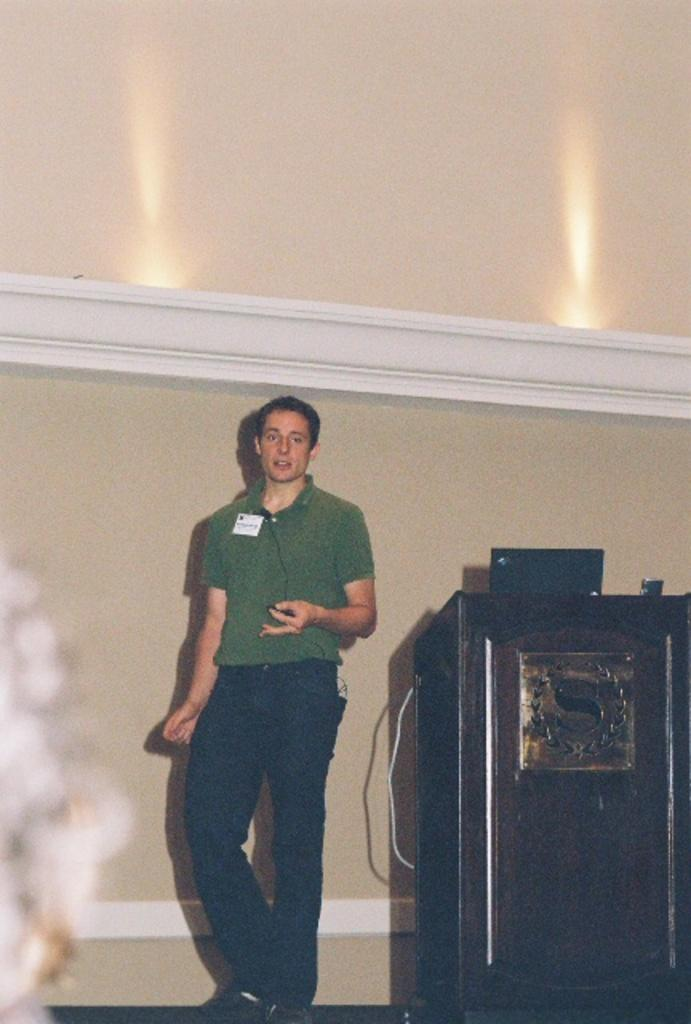What is the main subject of the image? The main subject of the image is a man standing. Where is the man standing in the image? The man is standing on the floor. What object can be seen in the image besides the man? There is a podium in the image. What is visible in the background of the image? There is a wall in the background of the image. What word is written on the tub in the image? There is no tub present in the image, so it is not possible to answer that question. 